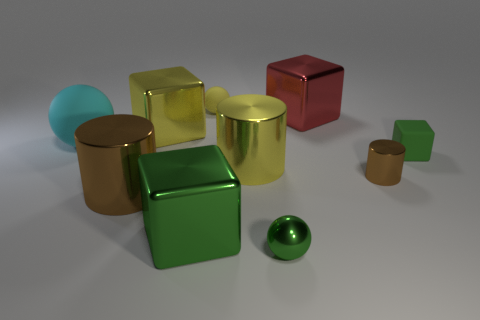What number of other things are there of the same material as the big red block
Give a very brief answer. 6. What number of matte things are big balls or large yellow objects?
Offer a very short reply. 1. The other metal thing that is the same shape as the large cyan object is what color?
Ensure brevity in your answer.  Green. What number of objects are either large yellow cylinders or red metallic spheres?
Your answer should be very brief. 1. There is a tiny green thing that is made of the same material as the large brown object; what shape is it?
Provide a succinct answer. Sphere. How many small objects are green shiny spheres or brown cylinders?
Keep it short and to the point. 2. How many other objects are there of the same color as the small rubber block?
Make the answer very short. 2. There is a brown shiny object to the right of the brown object that is to the left of the large green thing; how many yellow rubber things are to the right of it?
Offer a terse response. 0. There is a brown metallic object left of the yellow matte thing; is its size the same as the small green ball?
Provide a short and direct response. No. Are there fewer tiny yellow things to the left of the big green thing than metallic cubes that are right of the yellow ball?
Ensure brevity in your answer.  Yes. 